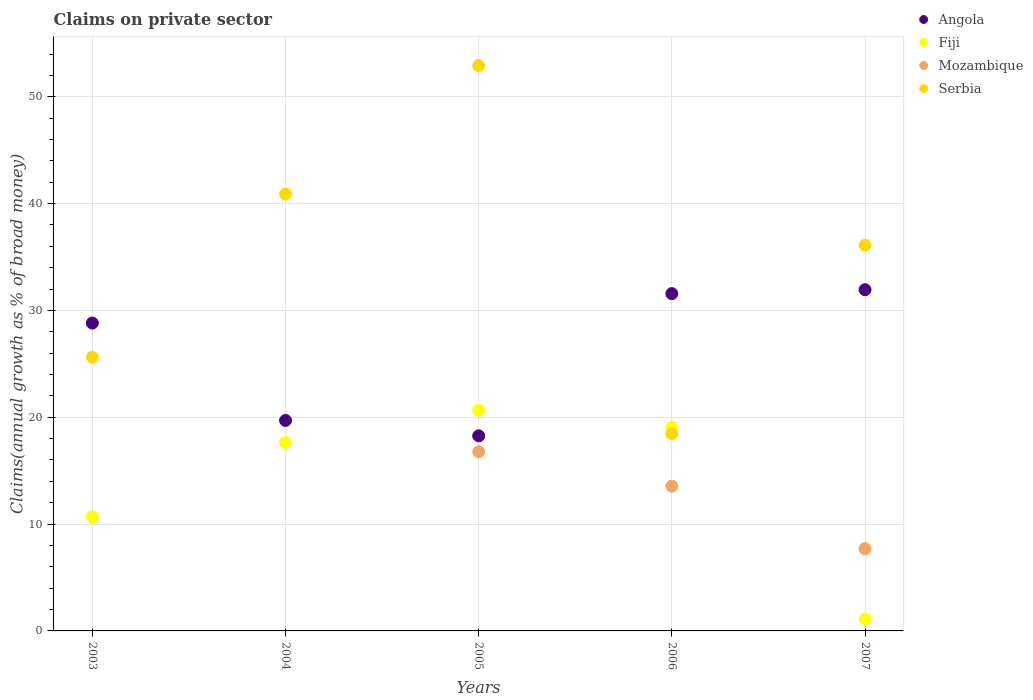How many different coloured dotlines are there?
Offer a terse response. 4. Is the number of dotlines equal to the number of legend labels?
Make the answer very short. No. What is the percentage of broad money claimed on private sector in Mozambique in 2005?
Offer a very short reply. 16.78. Across all years, what is the maximum percentage of broad money claimed on private sector in Fiji?
Provide a succinct answer. 20.67. Across all years, what is the minimum percentage of broad money claimed on private sector in Fiji?
Ensure brevity in your answer.  1.11. What is the total percentage of broad money claimed on private sector in Angola in the graph?
Give a very brief answer. 130.29. What is the difference between the percentage of broad money claimed on private sector in Mozambique in 2005 and that in 2007?
Give a very brief answer. 9.08. What is the difference between the percentage of broad money claimed on private sector in Angola in 2003 and the percentage of broad money claimed on private sector in Mozambique in 2005?
Give a very brief answer. 12.04. What is the average percentage of broad money claimed on private sector in Mozambique per year?
Provide a succinct answer. 7.61. In the year 2004, what is the difference between the percentage of broad money claimed on private sector in Serbia and percentage of broad money claimed on private sector in Angola?
Provide a short and direct response. 21.19. What is the ratio of the percentage of broad money claimed on private sector in Mozambique in 2006 to that in 2007?
Keep it short and to the point. 1.76. Is the difference between the percentage of broad money claimed on private sector in Serbia in 2004 and 2006 greater than the difference between the percentage of broad money claimed on private sector in Angola in 2004 and 2006?
Give a very brief answer. Yes. What is the difference between the highest and the second highest percentage of broad money claimed on private sector in Mozambique?
Keep it short and to the point. 3.23. What is the difference between the highest and the lowest percentage of broad money claimed on private sector in Serbia?
Provide a short and direct response. 34.45. Is it the case that in every year, the sum of the percentage of broad money claimed on private sector in Serbia and percentage of broad money claimed on private sector in Fiji  is greater than the sum of percentage of broad money claimed on private sector in Mozambique and percentage of broad money claimed on private sector in Angola?
Keep it short and to the point. No. Does the percentage of broad money claimed on private sector in Angola monotonically increase over the years?
Make the answer very short. No. Is the percentage of broad money claimed on private sector in Angola strictly less than the percentage of broad money claimed on private sector in Serbia over the years?
Offer a very short reply. No. How many dotlines are there?
Keep it short and to the point. 4. What is the difference between two consecutive major ticks on the Y-axis?
Your response must be concise. 10. Where does the legend appear in the graph?
Keep it short and to the point. Top right. How are the legend labels stacked?
Provide a succinct answer. Vertical. What is the title of the graph?
Your answer should be very brief. Claims on private sector. Does "Sweden" appear as one of the legend labels in the graph?
Offer a very short reply. No. What is the label or title of the X-axis?
Provide a succinct answer. Years. What is the label or title of the Y-axis?
Keep it short and to the point. Claims(annual growth as % of broad money). What is the Claims(annual growth as % of broad money) in Angola in 2003?
Your response must be concise. 28.82. What is the Claims(annual growth as % of broad money) of Fiji in 2003?
Offer a very short reply. 10.68. What is the Claims(annual growth as % of broad money) of Mozambique in 2003?
Your response must be concise. 0. What is the Claims(annual growth as % of broad money) of Serbia in 2003?
Your answer should be very brief. 25.61. What is the Claims(annual growth as % of broad money) in Angola in 2004?
Offer a terse response. 19.7. What is the Claims(annual growth as % of broad money) in Fiji in 2004?
Make the answer very short. 17.63. What is the Claims(annual growth as % of broad money) of Serbia in 2004?
Your answer should be compact. 40.89. What is the Claims(annual growth as % of broad money) in Angola in 2005?
Provide a succinct answer. 18.26. What is the Claims(annual growth as % of broad money) of Fiji in 2005?
Your answer should be very brief. 20.67. What is the Claims(annual growth as % of broad money) in Mozambique in 2005?
Provide a short and direct response. 16.78. What is the Claims(annual growth as % of broad money) of Serbia in 2005?
Keep it short and to the point. 52.91. What is the Claims(annual growth as % of broad money) of Angola in 2006?
Your response must be concise. 31.57. What is the Claims(annual growth as % of broad money) of Fiji in 2006?
Ensure brevity in your answer.  19.09. What is the Claims(annual growth as % of broad money) of Mozambique in 2006?
Ensure brevity in your answer.  13.55. What is the Claims(annual growth as % of broad money) in Serbia in 2006?
Offer a terse response. 18.47. What is the Claims(annual growth as % of broad money) in Angola in 2007?
Ensure brevity in your answer.  31.94. What is the Claims(annual growth as % of broad money) in Fiji in 2007?
Ensure brevity in your answer.  1.11. What is the Claims(annual growth as % of broad money) in Mozambique in 2007?
Offer a very short reply. 7.7. What is the Claims(annual growth as % of broad money) of Serbia in 2007?
Give a very brief answer. 36.11. Across all years, what is the maximum Claims(annual growth as % of broad money) of Angola?
Ensure brevity in your answer.  31.94. Across all years, what is the maximum Claims(annual growth as % of broad money) of Fiji?
Provide a short and direct response. 20.67. Across all years, what is the maximum Claims(annual growth as % of broad money) of Mozambique?
Provide a succinct answer. 16.78. Across all years, what is the maximum Claims(annual growth as % of broad money) in Serbia?
Provide a short and direct response. 52.91. Across all years, what is the minimum Claims(annual growth as % of broad money) of Angola?
Give a very brief answer. 18.26. Across all years, what is the minimum Claims(annual growth as % of broad money) in Fiji?
Your response must be concise. 1.11. Across all years, what is the minimum Claims(annual growth as % of broad money) in Serbia?
Provide a succinct answer. 18.47. What is the total Claims(annual growth as % of broad money) of Angola in the graph?
Ensure brevity in your answer.  130.29. What is the total Claims(annual growth as % of broad money) of Fiji in the graph?
Your answer should be very brief. 69.18. What is the total Claims(annual growth as % of broad money) in Mozambique in the graph?
Offer a very short reply. 38.03. What is the total Claims(annual growth as % of broad money) of Serbia in the graph?
Your answer should be compact. 174. What is the difference between the Claims(annual growth as % of broad money) of Angola in 2003 and that in 2004?
Your answer should be compact. 9.12. What is the difference between the Claims(annual growth as % of broad money) of Fiji in 2003 and that in 2004?
Offer a very short reply. -6.95. What is the difference between the Claims(annual growth as % of broad money) in Serbia in 2003 and that in 2004?
Offer a very short reply. -15.28. What is the difference between the Claims(annual growth as % of broad money) of Angola in 2003 and that in 2005?
Ensure brevity in your answer.  10.56. What is the difference between the Claims(annual growth as % of broad money) in Fiji in 2003 and that in 2005?
Make the answer very short. -9.98. What is the difference between the Claims(annual growth as % of broad money) of Serbia in 2003 and that in 2005?
Offer a very short reply. -27.3. What is the difference between the Claims(annual growth as % of broad money) in Angola in 2003 and that in 2006?
Keep it short and to the point. -2.75. What is the difference between the Claims(annual growth as % of broad money) of Fiji in 2003 and that in 2006?
Your answer should be very brief. -8.4. What is the difference between the Claims(annual growth as % of broad money) of Serbia in 2003 and that in 2006?
Offer a terse response. 7.15. What is the difference between the Claims(annual growth as % of broad money) in Angola in 2003 and that in 2007?
Provide a short and direct response. -3.12. What is the difference between the Claims(annual growth as % of broad money) of Fiji in 2003 and that in 2007?
Make the answer very short. 9.57. What is the difference between the Claims(annual growth as % of broad money) of Serbia in 2003 and that in 2007?
Ensure brevity in your answer.  -10.5. What is the difference between the Claims(annual growth as % of broad money) in Angola in 2004 and that in 2005?
Ensure brevity in your answer.  1.44. What is the difference between the Claims(annual growth as % of broad money) in Fiji in 2004 and that in 2005?
Ensure brevity in your answer.  -3.04. What is the difference between the Claims(annual growth as % of broad money) in Serbia in 2004 and that in 2005?
Make the answer very short. -12.02. What is the difference between the Claims(annual growth as % of broad money) of Angola in 2004 and that in 2006?
Your answer should be very brief. -11.87. What is the difference between the Claims(annual growth as % of broad money) of Fiji in 2004 and that in 2006?
Offer a very short reply. -1.45. What is the difference between the Claims(annual growth as % of broad money) of Serbia in 2004 and that in 2006?
Provide a short and direct response. 22.42. What is the difference between the Claims(annual growth as % of broad money) of Angola in 2004 and that in 2007?
Offer a terse response. -12.24. What is the difference between the Claims(annual growth as % of broad money) of Fiji in 2004 and that in 2007?
Offer a terse response. 16.52. What is the difference between the Claims(annual growth as % of broad money) of Serbia in 2004 and that in 2007?
Ensure brevity in your answer.  4.78. What is the difference between the Claims(annual growth as % of broad money) of Angola in 2005 and that in 2006?
Make the answer very short. -13.31. What is the difference between the Claims(annual growth as % of broad money) of Fiji in 2005 and that in 2006?
Offer a very short reply. 1.58. What is the difference between the Claims(annual growth as % of broad money) of Mozambique in 2005 and that in 2006?
Provide a succinct answer. 3.23. What is the difference between the Claims(annual growth as % of broad money) of Serbia in 2005 and that in 2006?
Your answer should be compact. 34.45. What is the difference between the Claims(annual growth as % of broad money) of Angola in 2005 and that in 2007?
Keep it short and to the point. -13.68. What is the difference between the Claims(annual growth as % of broad money) of Fiji in 2005 and that in 2007?
Offer a very short reply. 19.56. What is the difference between the Claims(annual growth as % of broad money) in Mozambique in 2005 and that in 2007?
Make the answer very short. 9.08. What is the difference between the Claims(annual growth as % of broad money) in Serbia in 2005 and that in 2007?
Give a very brief answer. 16.8. What is the difference between the Claims(annual growth as % of broad money) in Angola in 2006 and that in 2007?
Provide a short and direct response. -0.37. What is the difference between the Claims(annual growth as % of broad money) in Fiji in 2006 and that in 2007?
Your answer should be very brief. 17.98. What is the difference between the Claims(annual growth as % of broad money) in Mozambique in 2006 and that in 2007?
Your answer should be compact. 5.85. What is the difference between the Claims(annual growth as % of broad money) in Serbia in 2006 and that in 2007?
Keep it short and to the point. -17.64. What is the difference between the Claims(annual growth as % of broad money) of Angola in 2003 and the Claims(annual growth as % of broad money) of Fiji in 2004?
Offer a very short reply. 11.19. What is the difference between the Claims(annual growth as % of broad money) of Angola in 2003 and the Claims(annual growth as % of broad money) of Serbia in 2004?
Your answer should be compact. -12.07. What is the difference between the Claims(annual growth as % of broad money) of Fiji in 2003 and the Claims(annual growth as % of broad money) of Serbia in 2004?
Provide a short and direct response. -30.21. What is the difference between the Claims(annual growth as % of broad money) in Angola in 2003 and the Claims(annual growth as % of broad money) in Fiji in 2005?
Ensure brevity in your answer.  8.15. What is the difference between the Claims(annual growth as % of broad money) in Angola in 2003 and the Claims(annual growth as % of broad money) in Mozambique in 2005?
Provide a succinct answer. 12.04. What is the difference between the Claims(annual growth as % of broad money) in Angola in 2003 and the Claims(annual growth as % of broad money) in Serbia in 2005?
Offer a very short reply. -24.1. What is the difference between the Claims(annual growth as % of broad money) of Fiji in 2003 and the Claims(annual growth as % of broad money) of Mozambique in 2005?
Ensure brevity in your answer.  -6.1. What is the difference between the Claims(annual growth as % of broad money) in Fiji in 2003 and the Claims(annual growth as % of broad money) in Serbia in 2005?
Provide a short and direct response. -42.23. What is the difference between the Claims(annual growth as % of broad money) of Angola in 2003 and the Claims(annual growth as % of broad money) of Fiji in 2006?
Give a very brief answer. 9.73. What is the difference between the Claims(annual growth as % of broad money) in Angola in 2003 and the Claims(annual growth as % of broad money) in Mozambique in 2006?
Provide a succinct answer. 15.27. What is the difference between the Claims(annual growth as % of broad money) of Angola in 2003 and the Claims(annual growth as % of broad money) of Serbia in 2006?
Your response must be concise. 10.35. What is the difference between the Claims(annual growth as % of broad money) of Fiji in 2003 and the Claims(annual growth as % of broad money) of Mozambique in 2006?
Ensure brevity in your answer.  -2.87. What is the difference between the Claims(annual growth as % of broad money) of Fiji in 2003 and the Claims(annual growth as % of broad money) of Serbia in 2006?
Your response must be concise. -7.79. What is the difference between the Claims(annual growth as % of broad money) of Angola in 2003 and the Claims(annual growth as % of broad money) of Fiji in 2007?
Provide a short and direct response. 27.71. What is the difference between the Claims(annual growth as % of broad money) in Angola in 2003 and the Claims(annual growth as % of broad money) in Mozambique in 2007?
Ensure brevity in your answer.  21.12. What is the difference between the Claims(annual growth as % of broad money) of Angola in 2003 and the Claims(annual growth as % of broad money) of Serbia in 2007?
Offer a terse response. -7.29. What is the difference between the Claims(annual growth as % of broad money) of Fiji in 2003 and the Claims(annual growth as % of broad money) of Mozambique in 2007?
Ensure brevity in your answer.  2.99. What is the difference between the Claims(annual growth as % of broad money) of Fiji in 2003 and the Claims(annual growth as % of broad money) of Serbia in 2007?
Make the answer very short. -25.43. What is the difference between the Claims(annual growth as % of broad money) in Angola in 2004 and the Claims(annual growth as % of broad money) in Fiji in 2005?
Ensure brevity in your answer.  -0.97. What is the difference between the Claims(annual growth as % of broad money) of Angola in 2004 and the Claims(annual growth as % of broad money) of Mozambique in 2005?
Provide a succinct answer. 2.92. What is the difference between the Claims(annual growth as % of broad money) in Angola in 2004 and the Claims(annual growth as % of broad money) in Serbia in 2005?
Offer a very short reply. -33.21. What is the difference between the Claims(annual growth as % of broad money) in Fiji in 2004 and the Claims(annual growth as % of broad money) in Mozambique in 2005?
Offer a very short reply. 0.85. What is the difference between the Claims(annual growth as % of broad money) of Fiji in 2004 and the Claims(annual growth as % of broad money) of Serbia in 2005?
Make the answer very short. -35.28. What is the difference between the Claims(annual growth as % of broad money) of Angola in 2004 and the Claims(annual growth as % of broad money) of Fiji in 2006?
Your answer should be compact. 0.62. What is the difference between the Claims(annual growth as % of broad money) of Angola in 2004 and the Claims(annual growth as % of broad money) of Mozambique in 2006?
Offer a very short reply. 6.15. What is the difference between the Claims(annual growth as % of broad money) in Angola in 2004 and the Claims(annual growth as % of broad money) in Serbia in 2006?
Give a very brief answer. 1.23. What is the difference between the Claims(annual growth as % of broad money) of Fiji in 2004 and the Claims(annual growth as % of broad money) of Mozambique in 2006?
Your response must be concise. 4.08. What is the difference between the Claims(annual growth as % of broad money) of Fiji in 2004 and the Claims(annual growth as % of broad money) of Serbia in 2006?
Offer a very short reply. -0.84. What is the difference between the Claims(annual growth as % of broad money) in Angola in 2004 and the Claims(annual growth as % of broad money) in Fiji in 2007?
Keep it short and to the point. 18.59. What is the difference between the Claims(annual growth as % of broad money) in Angola in 2004 and the Claims(annual growth as % of broad money) in Mozambique in 2007?
Provide a succinct answer. 12. What is the difference between the Claims(annual growth as % of broad money) of Angola in 2004 and the Claims(annual growth as % of broad money) of Serbia in 2007?
Your response must be concise. -16.41. What is the difference between the Claims(annual growth as % of broad money) of Fiji in 2004 and the Claims(annual growth as % of broad money) of Mozambique in 2007?
Offer a very short reply. 9.93. What is the difference between the Claims(annual growth as % of broad money) of Fiji in 2004 and the Claims(annual growth as % of broad money) of Serbia in 2007?
Offer a terse response. -18.48. What is the difference between the Claims(annual growth as % of broad money) of Angola in 2005 and the Claims(annual growth as % of broad money) of Fiji in 2006?
Ensure brevity in your answer.  -0.82. What is the difference between the Claims(annual growth as % of broad money) in Angola in 2005 and the Claims(annual growth as % of broad money) in Mozambique in 2006?
Offer a terse response. 4.71. What is the difference between the Claims(annual growth as % of broad money) in Angola in 2005 and the Claims(annual growth as % of broad money) in Serbia in 2006?
Provide a short and direct response. -0.21. What is the difference between the Claims(annual growth as % of broad money) in Fiji in 2005 and the Claims(annual growth as % of broad money) in Mozambique in 2006?
Keep it short and to the point. 7.12. What is the difference between the Claims(annual growth as % of broad money) of Fiji in 2005 and the Claims(annual growth as % of broad money) of Serbia in 2006?
Provide a succinct answer. 2.2. What is the difference between the Claims(annual growth as % of broad money) of Mozambique in 2005 and the Claims(annual growth as % of broad money) of Serbia in 2006?
Provide a short and direct response. -1.69. What is the difference between the Claims(annual growth as % of broad money) of Angola in 2005 and the Claims(annual growth as % of broad money) of Fiji in 2007?
Make the answer very short. 17.15. What is the difference between the Claims(annual growth as % of broad money) of Angola in 2005 and the Claims(annual growth as % of broad money) of Mozambique in 2007?
Keep it short and to the point. 10.56. What is the difference between the Claims(annual growth as % of broad money) in Angola in 2005 and the Claims(annual growth as % of broad money) in Serbia in 2007?
Ensure brevity in your answer.  -17.85. What is the difference between the Claims(annual growth as % of broad money) in Fiji in 2005 and the Claims(annual growth as % of broad money) in Mozambique in 2007?
Provide a short and direct response. 12.97. What is the difference between the Claims(annual growth as % of broad money) of Fiji in 2005 and the Claims(annual growth as % of broad money) of Serbia in 2007?
Offer a terse response. -15.44. What is the difference between the Claims(annual growth as % of broad money) in Mozambique in 2005 and the Claims(annual growth as % of broad money) in Serbia in 2007?
Your answer should be very brief. -19.33. What is the difference between the Claims(annual growth as % of broad money) of Angola in 2006 and the Claims(annual growth as % of broad money) of Fiji in 2007?
Offer a terse response. 30.46. What is the difference between the Claims(annual growth as % of broad money) in Angola in 2006 and the Claims(annual growth as % of broad money) in Mozambique in 2007?
Provide a succinct answer. 23.88. What is the difference between the Claims(annual growth as % of broad money) of Angola in 2006 and the Claims(annual growth as % of broad money) of Serbia in 2007?
Provide a short and direct response. -4.54. What is the difference between the Claims(annual growth as % of broad money) of Fiji in 2006 and the Claims(annual growth as % of broad money) of Mozambique in 2007?
Provide a short and direct response. 11.39. What is the difference between the Claims(annual growth as % of broad money) of Fiji in 2006 and the Claims(annual growth as % of broad money) of Serbia in 2007?
Give a very brief answer. -17.03. What is the difference between the Claims(annual growth as % of broad money) in Mozambique in 2006 and the Claims(annual growth as % of broad money) in Serbia in 2007?
Ensure brevity in your answer.  -22.56. What is the average Claims(annual growth as % of broad money) in Angola per year?
Offer a terse response. 26.06. What is the average Claims(annual growth as % of broad money) in Fiji per year?
Provide a succinct answer. 13.84. What is the average Claims(annual growth as % of broad money) of Mozambique per year?
Ensure brevity in your answer.  7.61. What is the average Claims(annual growth as % of broad money) of Serbia per year?
Provide a short and direct response. 34.8. In the year 2003, what is the difference between the Claims(annual growth as % of broad money) in Angola and Claims(annual growth as % of broad money) in Fiji?
Keep it short and to the point. 18.13. In the year 2003, what is the difference between the Claims(annual growth as % of broad money) of Angola and Claims(annual growth as % of broad money) of Serbia?
Provide a short and direct response. 3.2. In the year 2003, what is the difference between the Claims(annual growth as % of broad money) of Fiji and Claims(annual growth as % of broad money) of Serbia?
Provide a short and direct response. -14.93. In the year 2004, what is the difference between the Claims(annual growth as % of broad money) in Angola and Claims(annual growth as % of broad money) in Fiji?
Your answer should be very brief. 2.07. In the year 2004, what is the difference between the Claims(annual growth as % of broad money) in Angola and Claims(annual growth as % of broad money) in Serbia?
Your answer should be very brief. -21.19. In the year 2004, what is the difference between the Claims(annual growth as % of broad money) of Fiji and Claims(annual growth as % of broad money) of Serbia?
Your answer should be very brief. -23.26. In the year 2005, what is the difference between the Claims(annual growth as % of broad money) in Angola and Claims(annual growth as % of broad money) in Fiji?
Your answer should be compact. -2.41. In the year 2005, what is the difference between the Claims(annual growth as % of broad money) in Angola and Claims(annual growth as % of broad money) in Mozambique?
Ensure brevity in your answer.  1.48. In the year 2005, what is the difference between the Claims(annual growth as % of broad money) in Angola and Claims(annual growth as % of broad money) in Serbia?
Offer a terse response. -34.65. In the year 2005, what is the difference between the Claims(annual growth as % of broad money) in Fiji and Claims(annual growth as % of broad money) in Mozambique?
Offer a terse response. 3.89. In the year 2005, what is the difference between the Claims(annual growth as % of broad money) of Fiji and Claims(annual growth as % of broad money) of Serbia?
Offer a terse response. -32.25. In the year 2005, what is the difference between the Claims(annual growth as % of broad money) in Mozambique and Claims(annual growth as % of broad money) in Serbia?
Give a very brief answer. -36.13. In the year 2006, what is the difference between the Claims(annual growth as % of broad money) of Angola and Claims(annual growth as % of broad money) of Fiji?
Provide a succinct answer. 12.49. In the year 2006, what is the difference between the Claims(annual growth as % of broad money) of Angola and Claims(annual growth as % of broad money) of Mozambique?
Give a very brief answer. 18.02. In the year 2006, what is the difference between the Claims(annual growth as % of broad money) in Angola and Claims(annual growth as % of broad money) in Serbia?
Offer a terse response. 13.1. In the year 2006, what is the difference between the Claims(annual growth as % of broad money) of Fiji and Claims(annual growth as % of broad money) of Mozambique?
Offer a terse response. 5.54. In the year 2006, what is the difference between the Claims(annual growth as % of broad money) in Fiji and Claims(annual growth as % of broad money) in Serbia?
Provide a succinct answer. 0.62. In the year 2006, what is the difference between the Claims(annual growth as % of broad money) of Mozambique and Claims(annual growth as % of broad money) of Serbia?
Your answer should be compact. -4.92. In the year 2007, what is the difference between the Claims(annual growth as % of broad money) in Angola and Claims(annual growth as % of broad money) in Fiji?
Keep it short and to the point. 30.83. In the year 2007, what is the difference between the Claims(annual growth as % of broad money) of Angola and Claims(annual growth as % of broad money) of Mozambique?
Your answer should be compact. 24.24. In the year 2007, what is the difference between the Claims(annual growth as % of broad money) of Angola and Claims(annual growth as % of broad money) of Serbia?
Offer a very short reply. -4.17. In the year 2007, what is the difference between the Claims(annual growth as % of broad money) of Fiji and Claims(annual growth as % of broad money) of Mozambique?
Provide a succinct answer. -6.59. In the year 2007, what is the difference between the Claims(annual growth as % of broad money) in Fiji and Claims(annual growth as % of broad money) in Serbia?
Your response must be concise. -35. In the year 2007, what is the difference between the Claims(annual growth as % of broad money) of Mozambique and Claims(annual growth as % of broad money) of Serbia?
Ensure brevity in your answer.  -28.41. What is the ratio of the Claims(annual growth as % of broad money) of Angola in 2003 to that in 2004?
Provide a succinct answer. 1.46. What is the ratio of the Claims(annual growth as % of broad money) of Fiji in 2003 to that in 2004?
Provide a short and direct response. 0.61. What is the ratio of the Claims(annual growth as % of broad money) in Serbia in 2003 to that in 2004?
Offer a very short reply. 0.63. What is the ratio of the Claims(annual growth as % of broad money) in Angola in 2003 to that in 2005?
Your response must be concise. 1.58. What is the ratio of the Claims(annual growth as % of broad money) of Fiji in 2003 to that in 2005?
Your answer should be compact. 0.52. What is the ratio of the Claims(annual growth as % of broad money) in Serbia in 2003 to that in 2005?
Offer a very short reply. 0.48. What is the ratio of the Claims(annual growth as % of broad money) of Angola in 2003 to that in 2006?
Your response must be concise. 0.91. What is the ratio of the Claims(annual growth as % of broad money) of Fiji in 2003 to that in 2006?
Your answer should be very brief. 0.56. What is the ratio of the Claims(annual growth as % of broad money) of Serbia in 2003 to that in 2006?
Make the answer very short. 1.39. What is the ratio of the Claims(annual growth as % of broad money) of Angola in 2003 to that in 2007?
Your answer should be compact. 0.9. What is the ratio of the Claims(annual growth as % of broad money) of Fiji in 2003 to that in 2007?
Keep it short and to the point. 9.62. What is the ratio of the Claims(annual growth as % of broad money) of Serbia in 2003 to that in 2007?
Ensure brevity in your answer.  0.71. What is the ratio of the Claims(annual growth as % of broad money) of Angola in 2004 to that in 2005?
Your response must be concise. 1.08. What is the ratio of the Claims(annual growth as % of broad money) of Fiji in 2004 to that in 2005?
Give a very brief answer. 0.85. What is the ratio of the Claims(annual growth as % of broad money) of Serbia in 2004 to that in 2005?
Keep it short and to the point. 0.77. What is the ratio of the Claims(annual growth as % of broad money) in Angola in 2004 to that in 2006?
Give a very brief answer. 0.62. What is the ratio of the Claims(annual growth as % of broad money) in Fiji in 2004 to that in 2006?
Keep it short and to the point. 0.92. What is the ratio of the Claims(annual growth as % of broad money) of Serbia in 2004 to that in 2006?
Provide a short and direct response. 2.21. What is the ratio of the Claims(annual growth as % of broad money) in Angola in 2004 to that in 2007?
Offer a terse response. 0.62. What is the ratio of the Claims(annual growth as % of broad money) in Fiji in 2004 to that in 2007?
Give a very brief answer. 15.88. What is the ratio of the Claims(annual growth as % of broad money) of Serbia in 2004 to that in 2007?
Offer a terse response. 1.13. What is the ratio of the Claims(annual growth as % of broad money) in Angola in 2005 to that in 2006?
Provide a succinct answer. 0.58. What is the ratio of the Claims(annual growth as % of broad money) of Fiji in 2005 to that in 2006?
Your answer should be very brief. 1.08. What is the ratio of the Claims(annual growth as % of broad money) of Mozambique in 2005 to that in 2006?
Offer a very short reply. 1.24. What is the ratio of the Claims(annual growth as % of broad money) of Serbia in 2005 to that in 2006?
Provide a short and direct response. 2.87. What is the ratio of the Claims(annual growth as % of broad money) in Angola in 2005 to that in 2007?
Ensure brevity in your answer.  0.57. What is the ratio of the Claims(annual growth as % of broad money) of Fiji in 2005 to that in 2007?
Offer a terse response. 18.62. What is the ratio of the Claims(annual growth as % of broad money) in Mozambique in 2005 to that in 2007?
Keep it short and to the point. 2.18. What is the ratio of the Claims(annual growth as % of broad money) in Serbia in 2005 to that in 2007?
Make the answer very short. 1.47. What is the ratio of the Claims(annual growth as % of broad money) in Angola in 2006 to that in 2007?
Make the answer very short. 0.99. What is the ratio of the Claims(annual growth as % of broad money) in Fiji in 2006 to that in 2007?
Your response must be concise. 17.19. What is the ratio of the Claims(annual growth as % of broad money) of Mozambique in 2006 to that in 2007?
Offer a terse response. 1.76. What is the ratio of the Claims(annual growth as % of broad money) in Serbia in 2006 to that in 2007?
Offer a terse response. 0.51. What is the difference between the highest and the second highest Claims(annual growth as % of broad money) in Angola?
Provide a succinct answer. 0.37. What is the difference between the highest and the second highest Claims(annual growth as % of broad money) in Fiji?
Ensure brevity in your answer.  1.58. What is the difference between the highest and the second highest Claims(annual growth as % of broad money) in Mozambique?
Your answer should be compact. 3.23. What is the difference between the highest and the second highest Claims(annual growth as % of broad money) in Serbia?
Make the answer very short. 12.02. What is the difference between the highest and the lowest Claims(annual growth as % of broad money) of Angola?
Your answer should be compact. 13.68. What is the difference between the highest and the lowest Claims(annual growth as % of broad money) in Fiji?
Offer a terse response. 19.56. What is the difference between the highest and the lowest Claims(annual growth as % of broad money) of Mozambique?
Make the answer very short. 16.78. What is the difference between the highest and the lowest Claims(annual growth as % of broad money) in Serbia?
Make the answer very short. 34.45. 